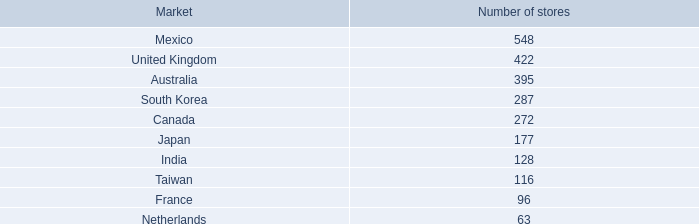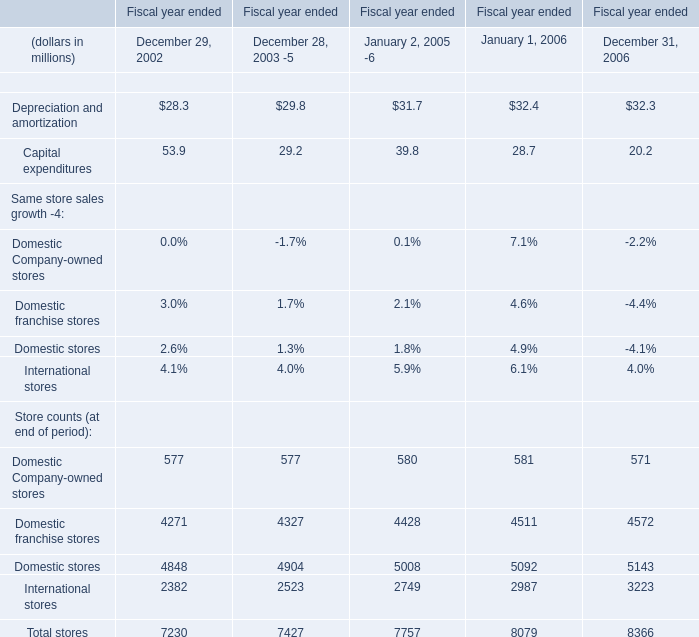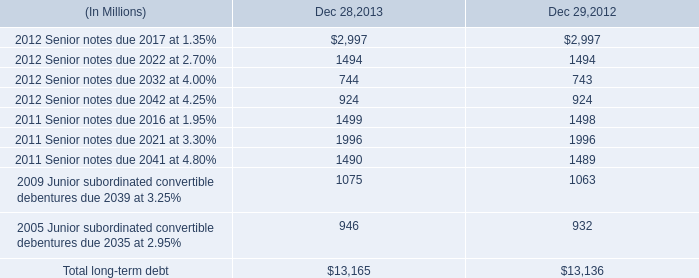If domestic stores develops with the same increasing rate in 2006, what will it reach in 2007? (in million) 
Computations: ((((5092 - 5008) / 5008) + 1) * 5092)
Answer: 5177.40895. 